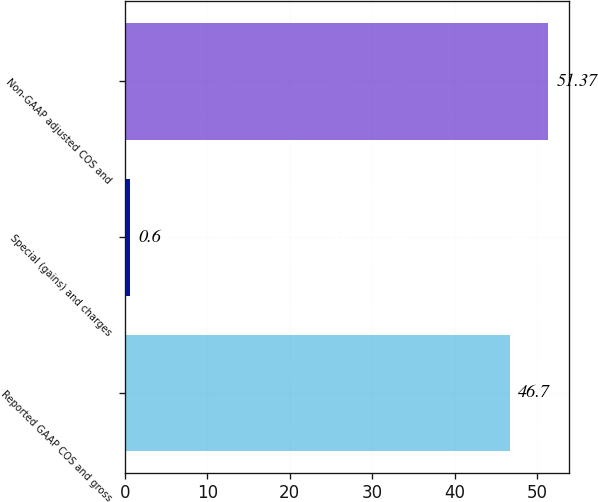Convert chart to OTSL. <chart><loc_0><loc_0><loc_500><loc_500><bar_chart><fcel>Reported GAAP COS and gross<fcel>Special (gains) and charges<fcel>Non-GAAP adjusted COS and<nl><fcel>46.7<fcel>0.6<fcel>51.37<nl></chart> 